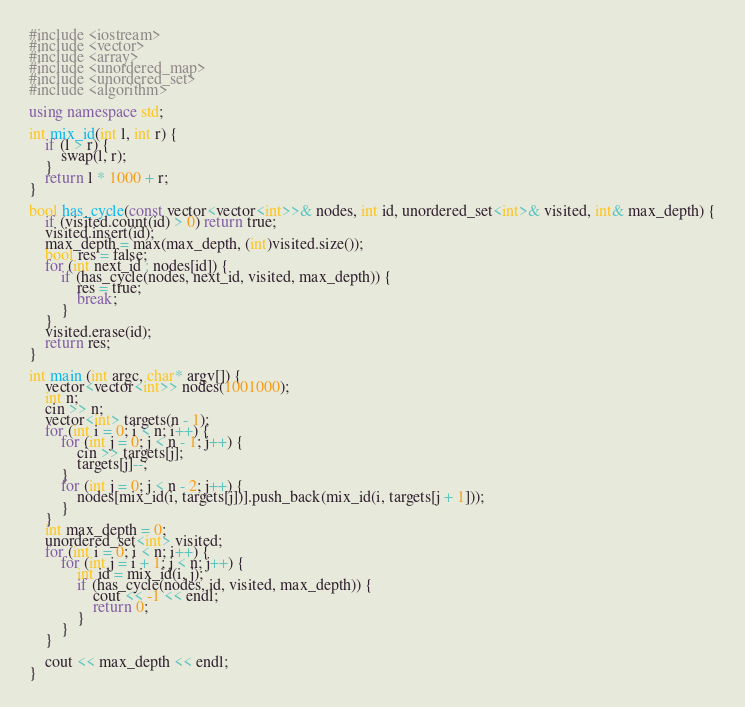Convert code to text. <code><loc_0><loc_0><loc_500><loc_500><_C++_>#include <iostream>
#include <vector>
#include <array>
#include <unordered_map>
#include <unordered_set>
#include <algorithm>

using namespace std;

int mix_id(int l, int r) {
	if (l > r) {
		swap(l, r);
	}
	return l * 1000 + r;
}

bool has_cycle(const vector<vector<int>>& nodes, int id, unordered_set<int>& visited, int& max_depth) {
	if (visited.count(id) > 0) return true;
	visited.insert(id);
	max_depth = max(max_depth, (int)visited.size());
	bool res = false;
	for (int next_id : nodes[id]) {
		if (has_cycle(nodes, next_id, visited, max_depth)) {
			res = true;
			break;
		}
	}
	visited.erase(id);
	return res;
}

int main (int argc, char* argv[]) {
	vector<vector<int>> nodes(1001000);
	int n;
	cin >> n;
	vector<int> targets(n - 1);
	for (int i = 0; i < n; i++) {
		for (int j = 0; j < n - 1; j++) {
			cin >> targets[j];
			targets[j]--;
		}
		for (int j = 0; j < n - 2; j++) {
			nodes[mix_id(i, targets[j])].push_back(mix_id(i, targets[j + 1]));
		}
	}
	int max_depth = 0;
	unordered_set<int> visited;
	for (int i = 0; i < n; i++) {
		for (int j = i + 1; j < n; j++) {
			int id = mix_id(i, j);
			if (has_cycle(nodes, id, visited, max_depth)) {
				cout << -1 << endl;
				return 0;
			}
		}
	}

	cout << max_depth << endl;
}
</code> 